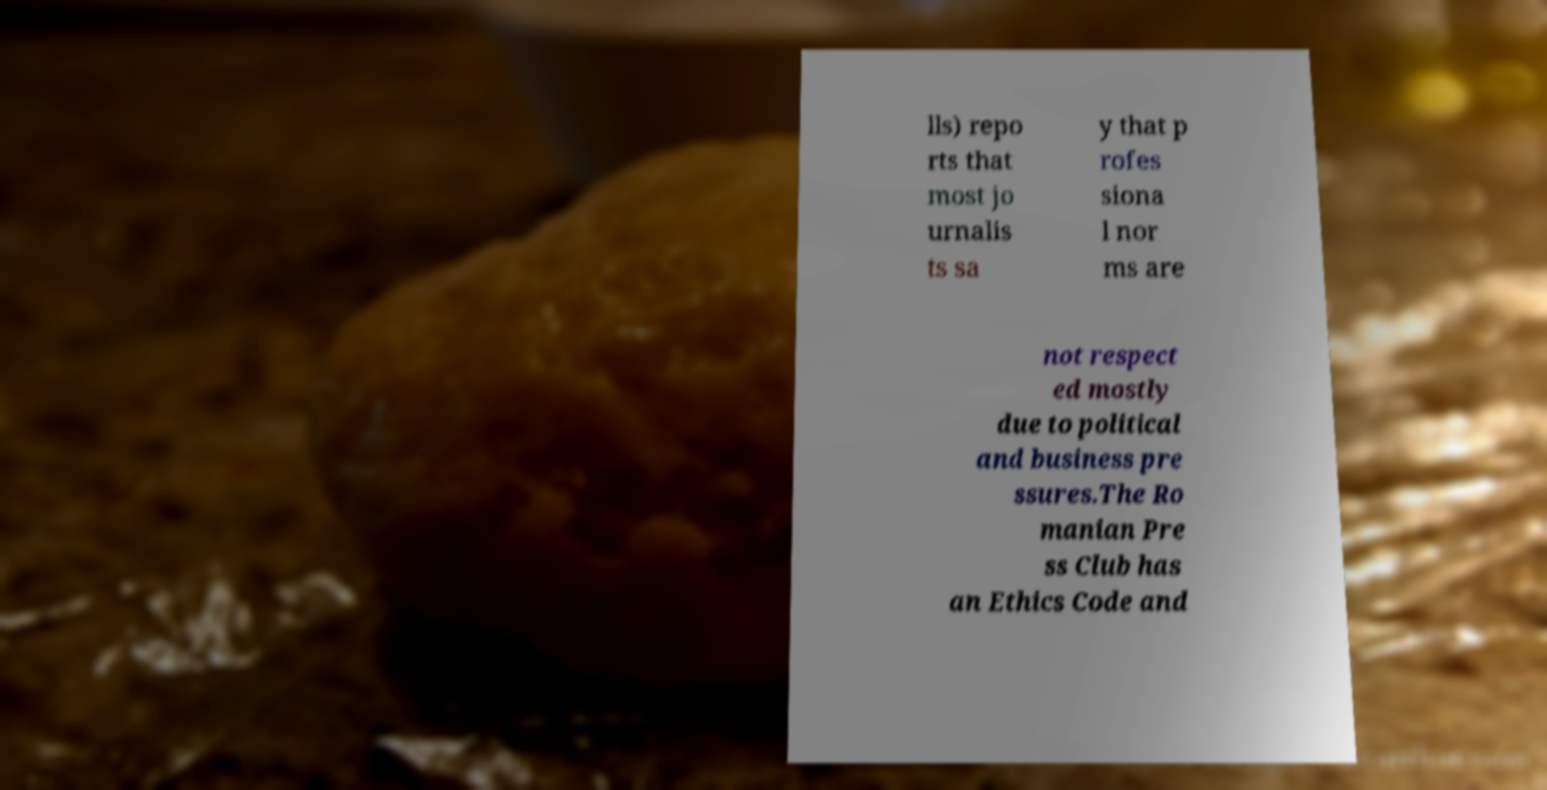Please read and relay the text visible in this image. What does it say? lls) repo rts that most jo urnalis ts sa y that p rofes siona l nor ms are not respect ed mostly due to political and business pre ssures.The Ro manian Pre ss Club has an Ethics Code and 